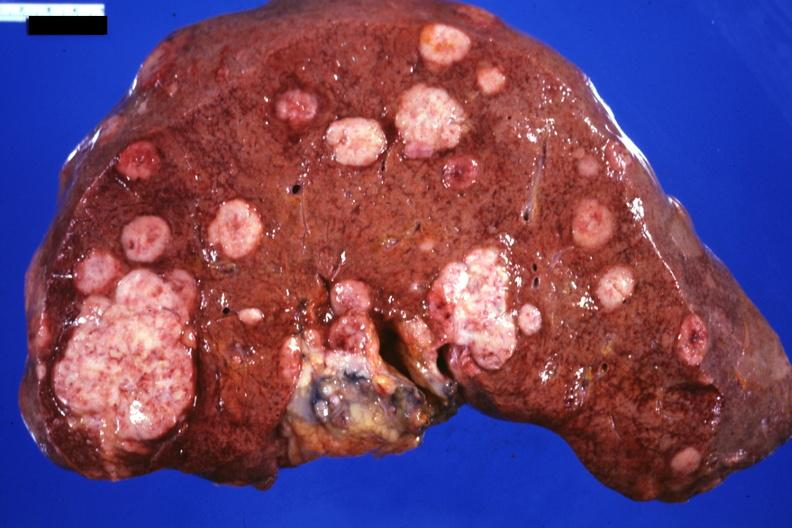s liver present?
Answer the question using a single word or phrase. Yes 